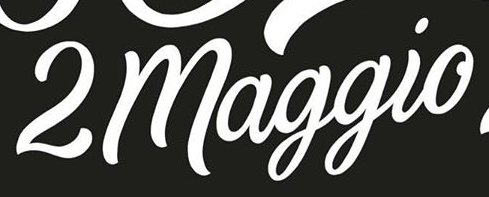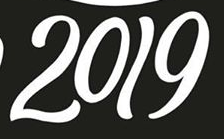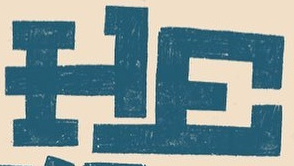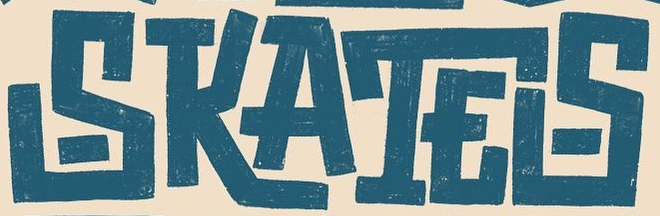What words are shown in these images in order, separated by a semicolon? 2maggio; 2019; HE; SKATES 